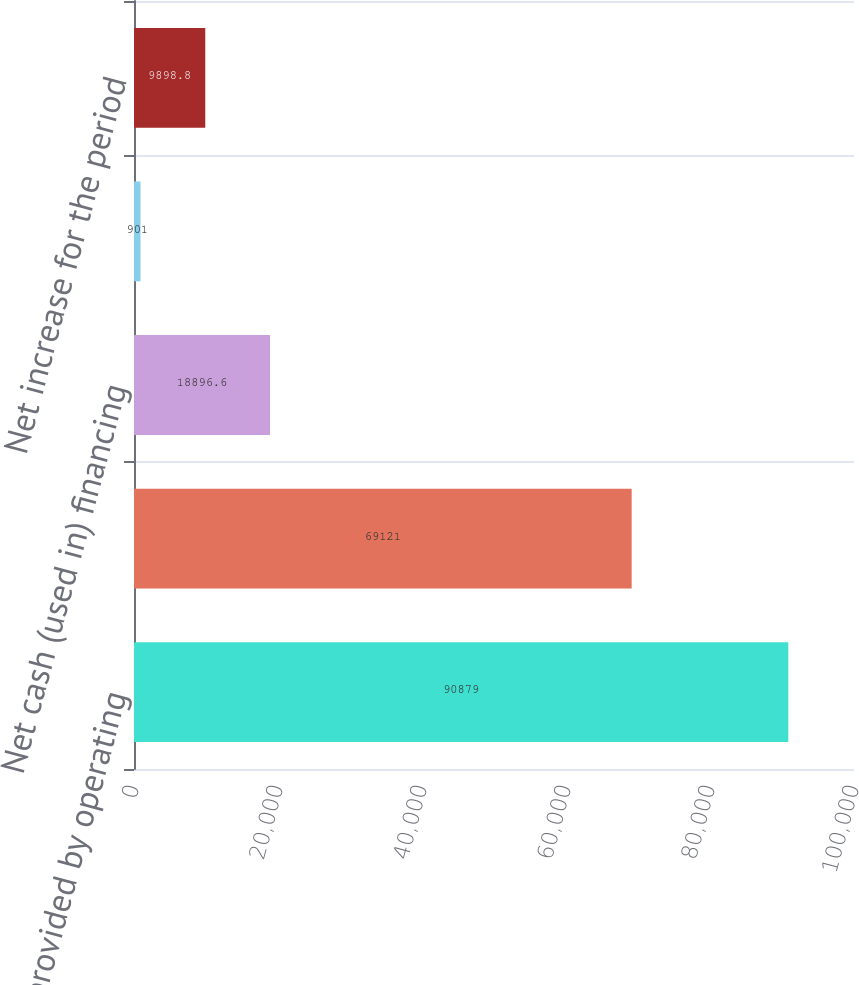Convert chart to OTSL. <chart><loc_0><loc_0><loc_500><loc_500><bar_chart><fcel>Net cash provided by operating<fcel>Net cash (used in) investing<fcel>Net cash (used in) financing<fcel>Effect of exchange rate<fcel>Net increase for the period<nl><fcel>90879<fcel>69121<fcel>18896.6<fcel>901<fcel>9898.8<nl></chart> 